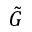<formula> <loc_0><loc_0><loc_500><loc_500>\tilde { G }</formula> 